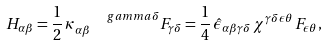Convert formula to latex. <formula><loc_0><loc_0><loc_500><loc_500>H _ { \alpha \beta } = \frac { 1 } { 2 } \, \kappa _ { \alpha \beta } ^ { \quad g a m m a \delta } F _ { \gamma \delta } = \frac { 1 } { 4 } \, { \hat { \epsilon } } _ { \alpha \beta \gamma \delta } \, \chi ^ { \gamma \delta \epsilon \theta } \, F _ { \epsilon \theta } ,</formula> 